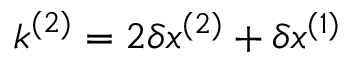<formula> <loc_0><loc_0><loc_500><loc_500>k ^ { ( 2 ) } = 2 \delta x ^ { ( 2 ) } + \delta x ^ { ( 1 ) }</formula> 